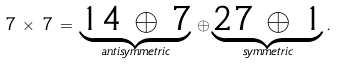<formula> <loc_0><loc_0><loc_500><loc_500>7 \, \times \, 7 \, = \, \underbrace { 1 4 \, \oplus \, 7 } _ { a n t i s y m m e t r i c } \, \oplus \underbrace { 2 7 \, \oplus \, 1 } _ { s y m m e t r i c } .</formula> 